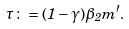<formula> <loc_0><loc_0><loc_500><loc_500>\tau \colon = ( 1 - \gamma ) \beta _ { 2 } m ^ { \prime } .</formula> 